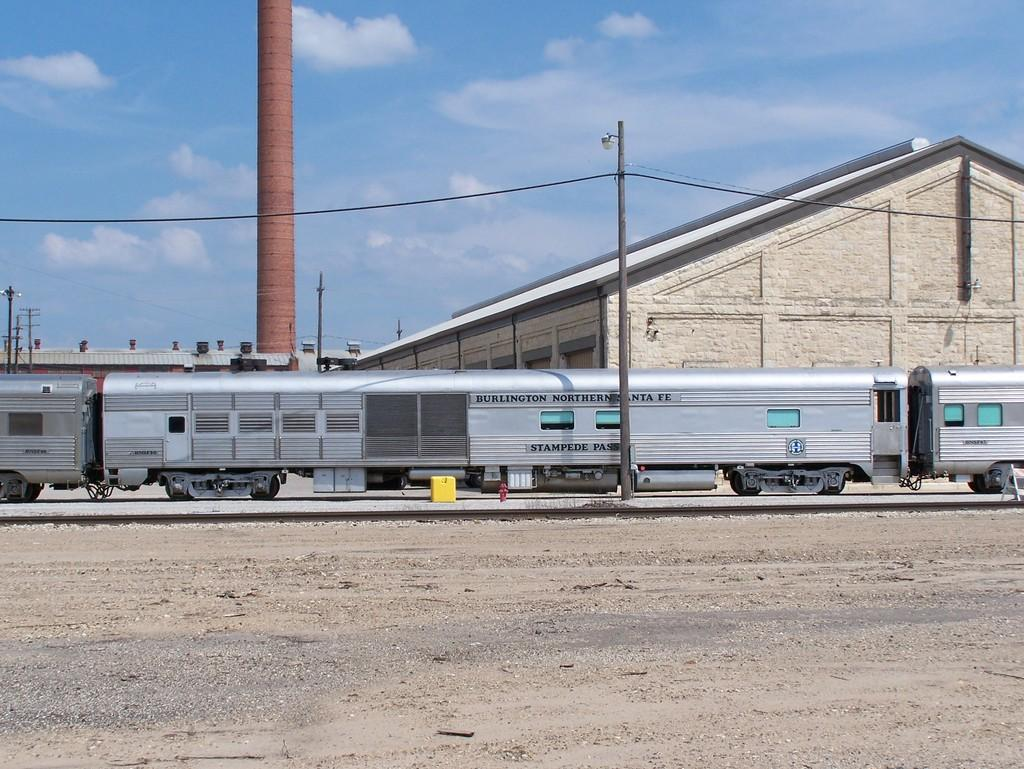Provide a one-sentence caption for the provided image. a Burlington northern Santa fe train passing by a warehouse. 